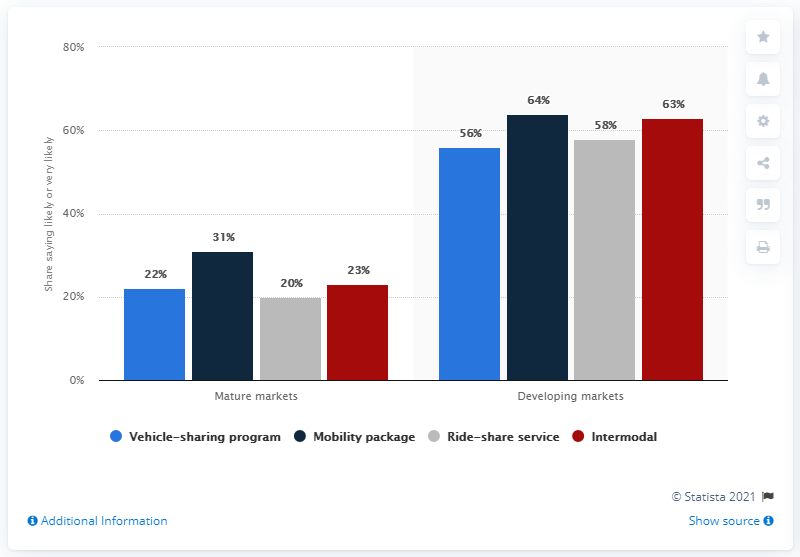Identify some key points in this picture. The sum of the values between 50 and 60 in the chart is 114. A recent survey suggests that approximately 31% of consumers in mature markets are likely to consider owning a mobility package in the near future. 